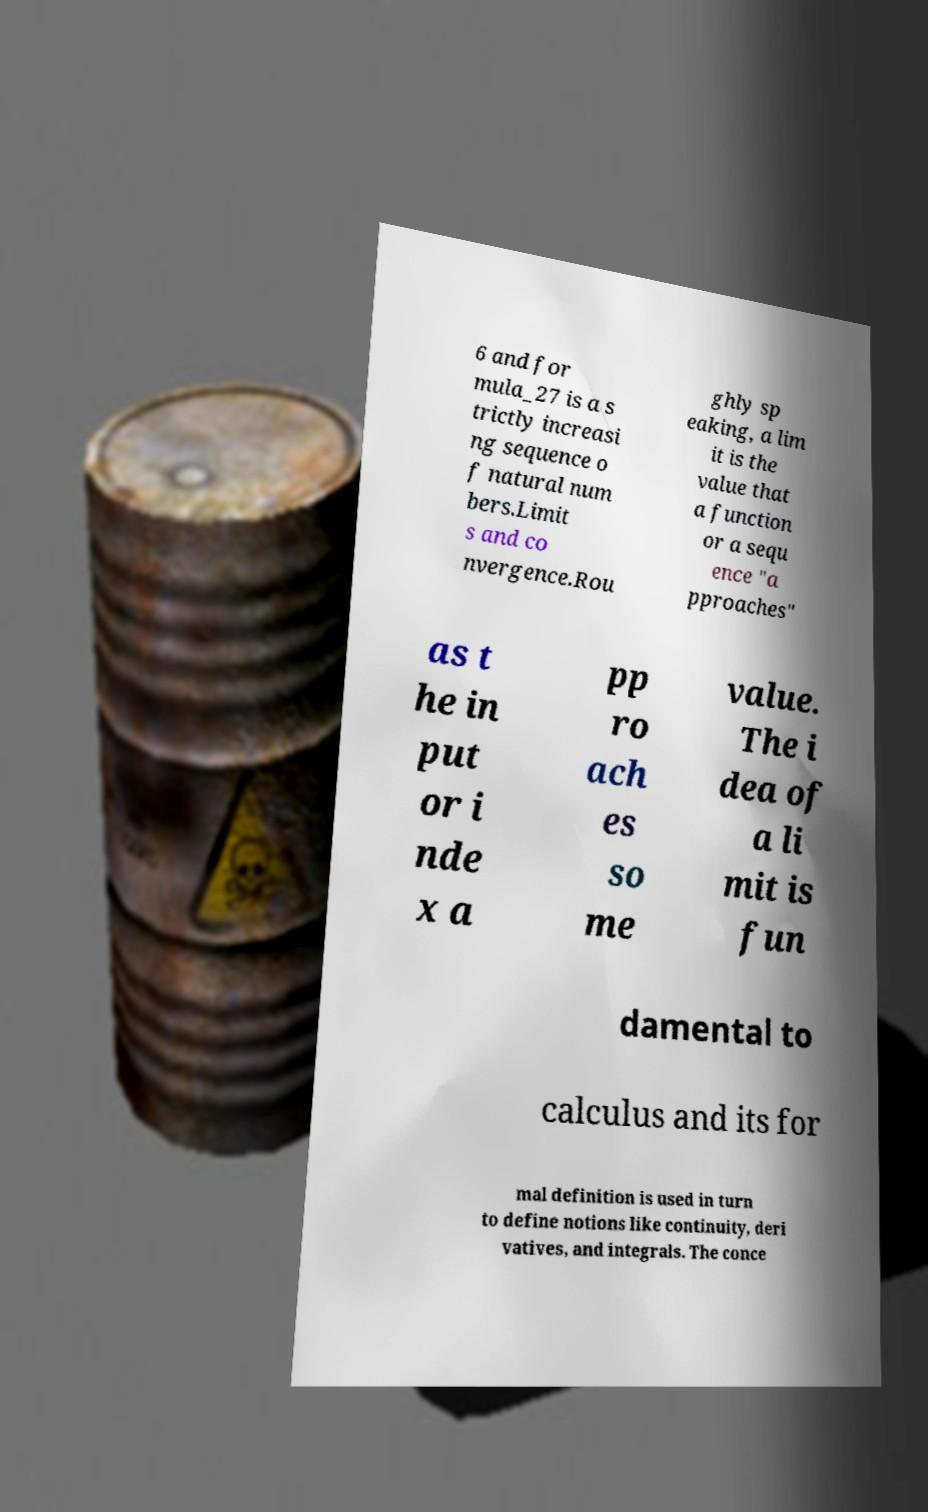Can you accurately transcribe the text from the provided image for me? 6 and for mula_27 is a s trictly increasi ng sequence o f natural num bers.Limit s and co nvergence.Rou ghly sp eaking, a lim it is the value that a function or a sequ ence "a pproaches" as t he in put or i nde x a pp ro ach es so me value. The i dea of a li mit is fun damental to calculus and its for mal definition is used in turn to define notions like continuity, deri vatives, and integrals. The conce 